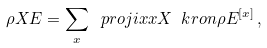<formula> <loc_0><loc_0><loc_500><loc_500>\rho X E = \sum _ { x } \ p r o j i { x } { x } { X } \ k r o n \rho E ^ { [ x ] } \, ,</formula> 